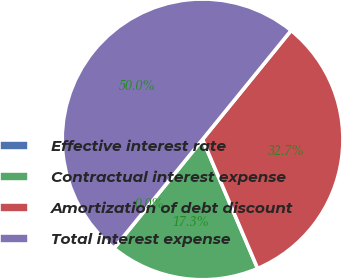<chart> <loc_0><loc_0><loc_500><loc_500><pie_chart><fcel>Effective interest rate<fcel>Contractual interest expense<fcel>Amortization of debt discount<fcel>Total interest expense<nl><fcel>0.01%<fcel>17.28%<fcel>32.72%<fcel>49.99%<nl></chart> 